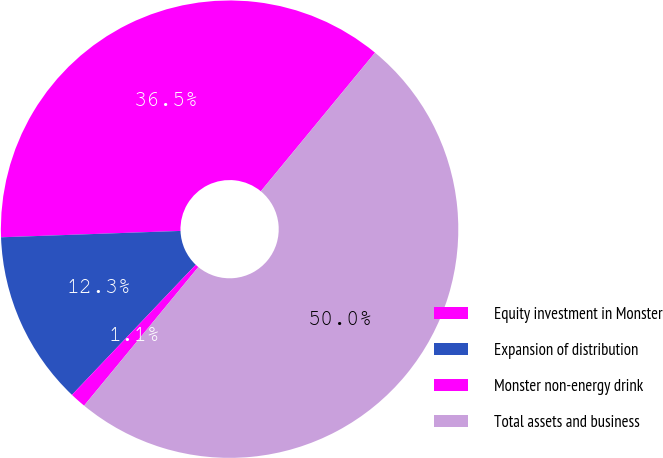Convert chart. <chart><loc_0><loc_0><loc_500><loc_500><pie_chart><fcel>Equity investment in Monster<fcel>Expansion of distribution<fcel>Monster non-energy drink<fcel>Total assets and business<nl><fcel>36.53%<fcel>12.33%<fcel>1.13%<fcel>50.0%<nl></chart> 